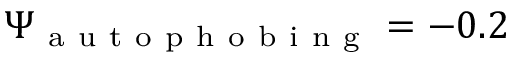Convert formula to latex. <formula><loc_0><loc_0><loc_500><loc_500>\Psi _ { a u t o p h o b i n g } = - 0 . 2</formula> 